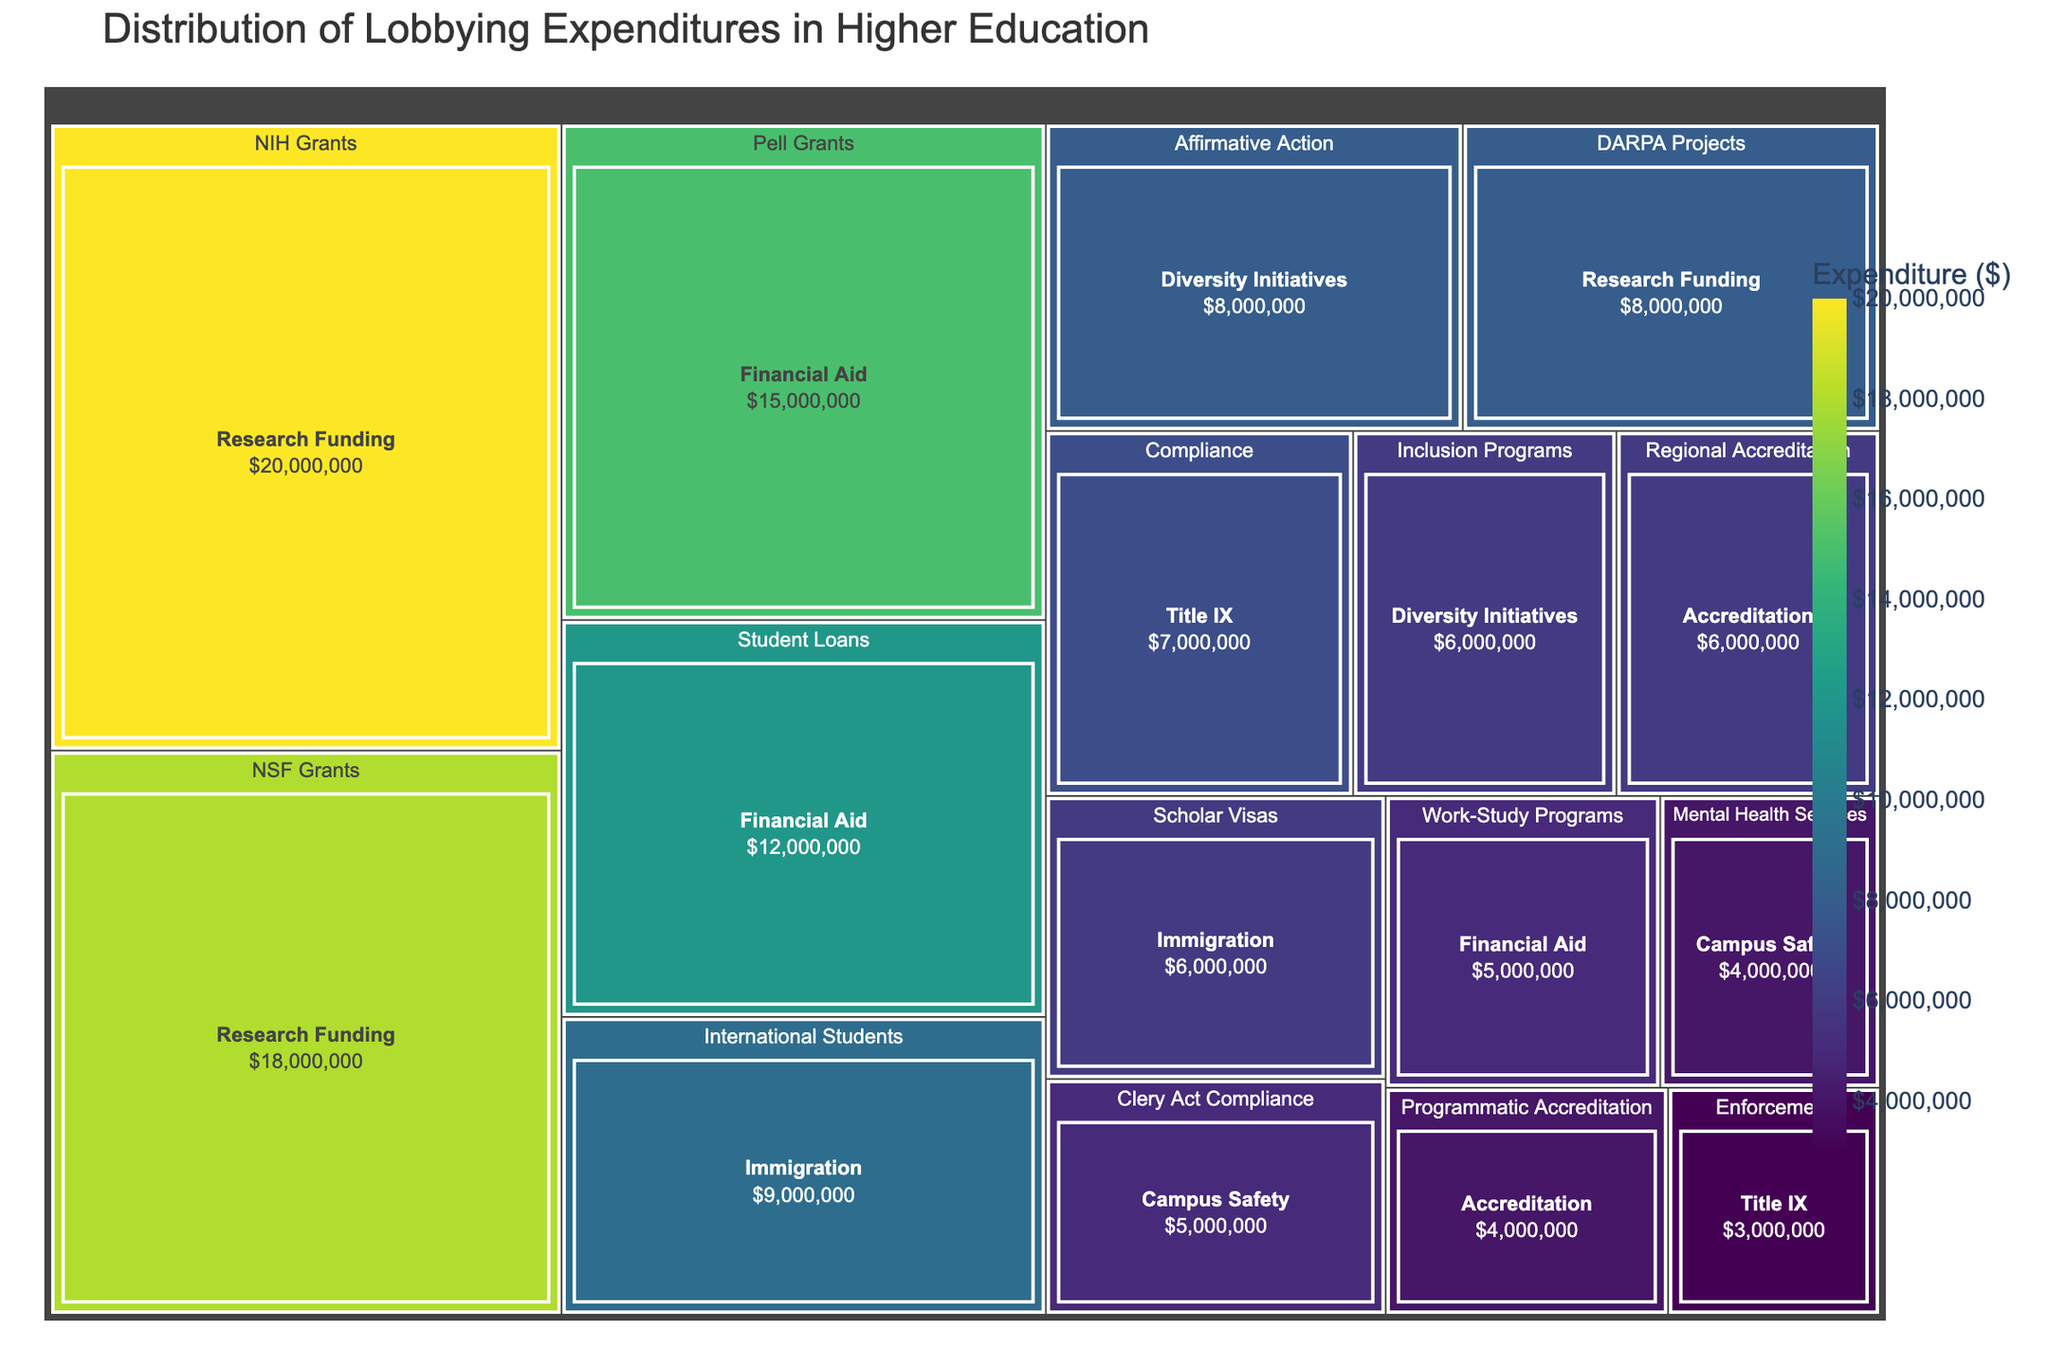What's the highest expenditure in a single policy area? The figure displays various policy areas with different expenditure levels. The policy area with the largest area (indicating highest expenditure) should be easily identified.
Answer: NIH Grants Which category has the most diverse allocation of lobbying expenditures? To find this, look at which category contains subcategories with a wide range of expenditures. The category with subcategories of significantly different sizes on the treemap indicates the most diverse allocation.
Answer: Research Funding What is the total expenditure on Financial Aid? Sum the expenditures of its subcategories: Pell Grants, Student Loans, and Work-Study Programs. Pell Grants ($15,000,000) + Student Loans ($12,000,000) + Work-Study Programs ($5,000,000) = $32,000,000
Answer: $32,000,000 Which specific policy area related to Title IX has higher expenditure? Compare the sizes of the individual tiles under Title IX, focusing on Compliance and Enforcement. The larger tile presents higher expenditure.
Answer: Compliance How does the expenditure on Accreditation compare to Immigration? Sum the expenditures for each. Accreditation: Regional Accreditation ($6,000,000) + Programmatic Accreditation ($4,000,000) = $10,000,000. Immigration: International Students ($9,000,000) + Scholar Visas ($6,000,000) = $15,000,000. Compare these sums.
Answer: Immigration has higher expenditure Which subcategory in Financial Aid has the lowest expenditure? Within the Financial Aid category, compare Pell Grants ($15,000,000), Student Loans ($12,000,000), and Work-Study Programs ($5,000,000). The smallest value indicates the lowest expenditure.
Answer: Work-Study Programs What's the combined expenditure for Title IX and Diversity Initiatives? Sum subcategories from both areas. Title IX: Compliance ($7,000,000) + Enforcement ($3,000,000) = $10,000,000. Diversity Initiatives: Affirmative Action ($8,000,000) + Inclusion Programs ($6,000,000) = $14,000,000. Add these totals.
Answer: $24,000,000 How much more is spent on NIH Grants compared to NSF Grants? Subtract the expenditure for NSF Grants from NIH Grants. NIH Grants ($20,000,000) - NSF Grants ($18,000,000) = $2,000,000
Answer: $2,000,000 